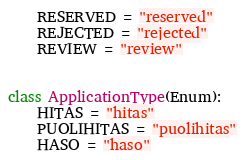Convert code to text. <code><loc_0><loc_0><loc_500><loc_500><_Python_>    RESERVED = "reserved"
    REJECTED = "rejected"
    REVIEW = "review"


class ApplicationType(Enum):
    HITAS = "hitas"
    PUOLIHITAS = "puolihitas"
    HASO = "haso"
</code> 